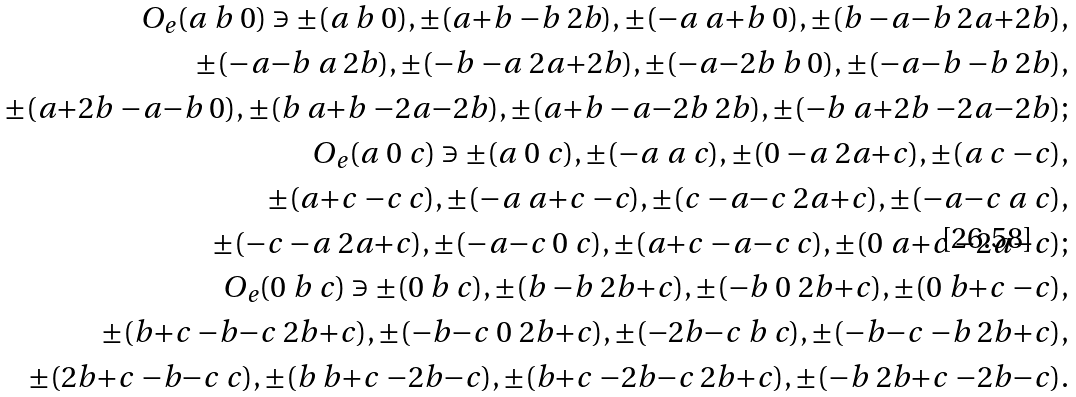<formula> <loc_0><loc_0><loc_500><loc_500>O _ { e } ( a \ b \ 0 ) \ni \pm ( a \ b \ 0 ) , \pm ( a { + } b \ { - } b \ 2 b ) , \pm ( { - } a \ a { + } b \ 0 ) , \pm ( b \ { - } a { - } b \ 2 a { + } 2 b ) , \\ \quad \pm ( { - } a { - } b \ a \ 2 b ) , \pm ( { - } b \ { - } a \ 2 a { + } 2 b ) , \pm ( { - } a { - } 2 b \ b \ 0 ) , \pm ( { - } a { - } b \ { - } b \ 2 b ) , \\ \quad \pm ( a { + } 2 b \ { - } a { - } b \ 0 ) , \pm ( b \ a { + } b \ { - } 2 a { - } 2 b ) , \pm ( a { + } b \ { - } a { - } 2 b \ 2 b ) , \pm ( { - } b \ a { + } 2 b \ { - } 2 a { - } 2 b ) ; \\ O _ { e } ( a \ 0 \ c ) \ni \pm ( a \ 0 \ c ) , \pm ( { - } a \ a \ c ) , \pm ( 0 \ { - } a \ 2 a { + } c ) , \pm ( a \ c \ { - } c ) , \\ \quad \pm ( a { + } c \ { - } c \ c ) , \pm ( { - } a \ a { + } c \ { - } c ) , \pm ( c \ { - } a { - } c \ 2 a { + } c ) , \pm ( { - } a { - } c \ a \ c ) , \\ \quad \pm ( { - } c \ { - } a \ 2 a { + } c ) , \pm ( { - } a { - } c \ 0 \ c ) , \pm ( a { + } c \ { - } a { - } c \ c ) , \pm ( 0 \ a { + } c \ { - } 2 a { - } c ) ; \\ O _ { e } ( 0 \ b \ c ) \ni \pm ( 0 \ b \ c ) , \pm ( b \ { - } b \ 2 b { + } c ) , \pm ( { - } b \ 0 \ 2 b { + } c ) , \pm ( 0 \ b { + } c \ { - } c ) , \\ \quad \pm ( b { + } c \ { - } b { - } c \ 2 b { + } c ) , \pm ( { - } b { - } c \ 0 \ 2 b { + } c ) , \pm ( { - } 2 b { - } c \ b \ c ) , \pm ( { - } b { - } c \ { - } b \ 2 b { + } c ) , \\ \quad \pm ( 2 b { + } c \ { - } b { - } c \ c ) , \pm ( b \ b { + } c \ { - } 2 b { - } c ) , \pm ( b { + } c \ { - } 2 b { - } c \ 2 b { + } c ) , \pm ( { - } b \ 2 b { + } c \ { - } 2 b { - } c ) .</formula> 